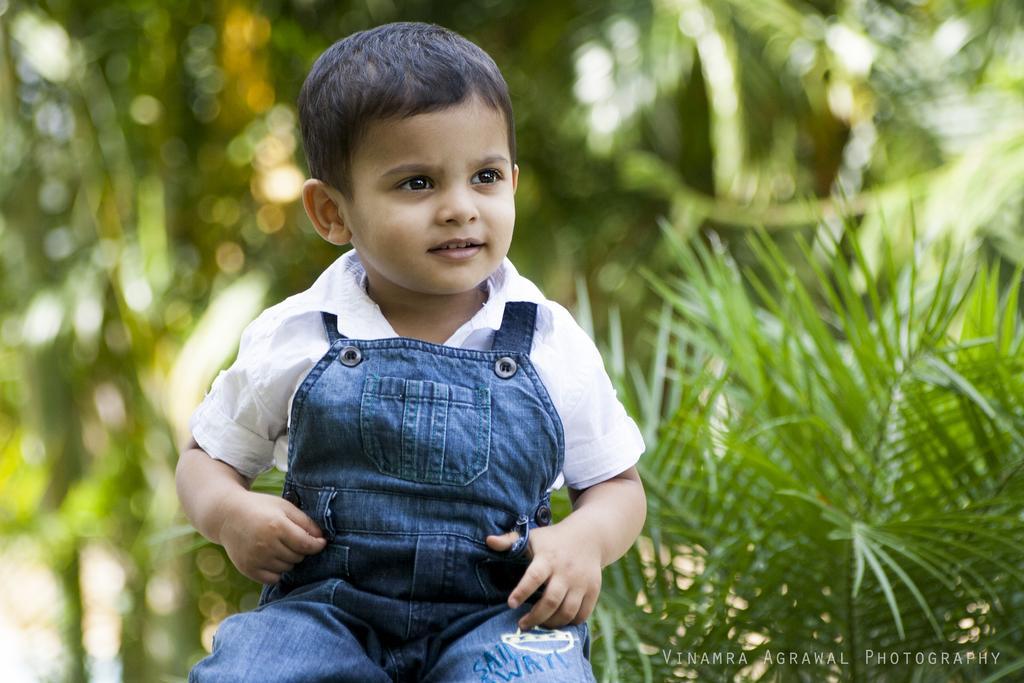Please provide a concise description of this image. Here I can see a child sitting and smiling by looking at the right side. In the background there are some plants. In the bottom right there is some edited text. 